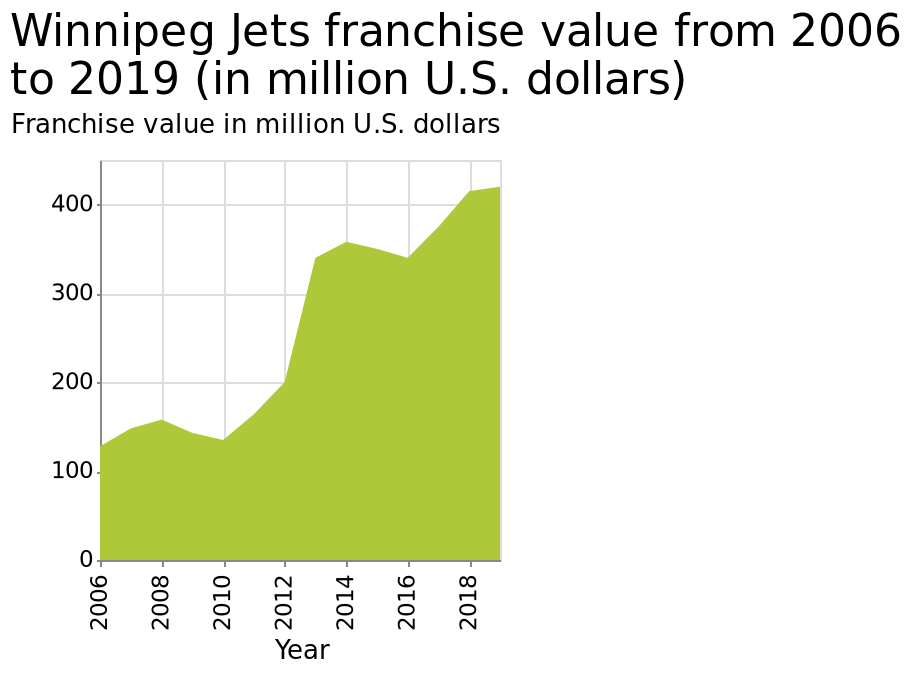<image>
Over what time period does the graph represent the Winnipeg Jets franchise value?  The graph represents the Winnipeg Jets franchise value from 2006 to 2019. 